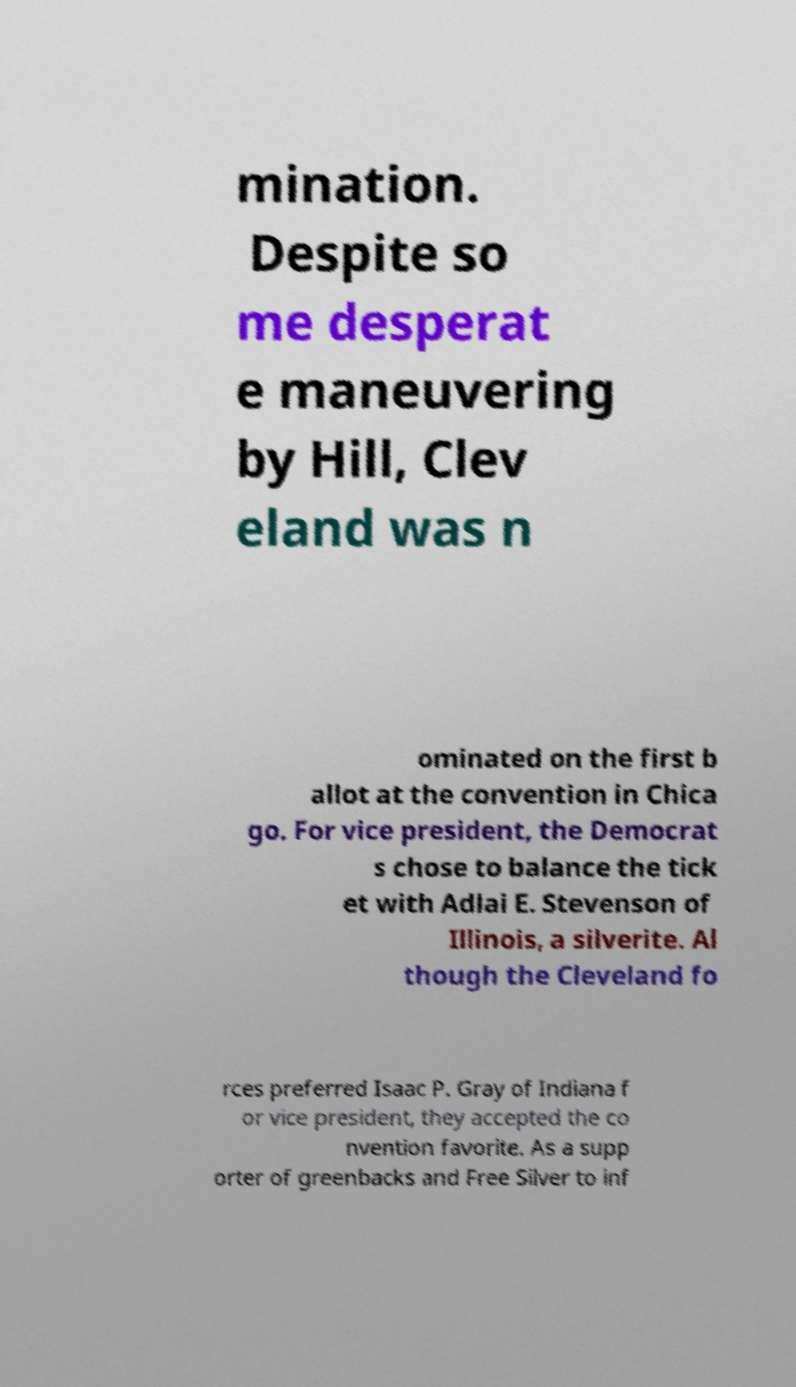What messages or text are displayed in this image? I need them in a readable, typed format. mination. Despite so me desperat e maneuvering by Hill, Clev eland was n ominated on the first b allot at the convention in Chica go. For vice president, the Democrat s chose to balance the tick et with Adlai E. Stevenson of Illinois, a silverite. Al though the Cleveland fo rces preferred Isaac P. Gray of Indiana f or vice president, they accepted the co nvention favorite. As a supp orter of greenbacks and Free Silver to inf 